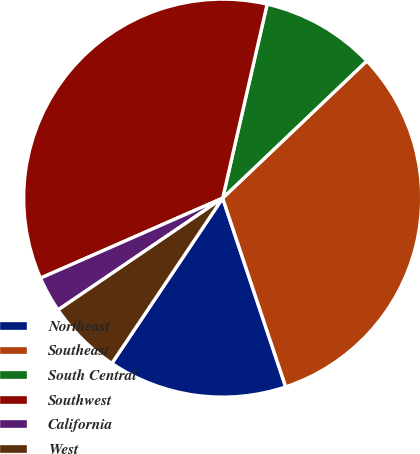<chart> <loc_0><loc_0><loc_500><loc_500><pie_chart><fcel>Northeast<fcel>Southeast<fcel>South Central<fcel>Southwest<fcel>California<fcel>West<nl><fcel>14.53%<fcel>31.98%<fcel>9.3%<fcel>35.17%<fcel>2.91%<fcel>6.1%<nl></chart> 